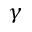Convert formula to latex. <formula><loc_0><loc_0><loc_500><loc_500>\gamma</formula> 